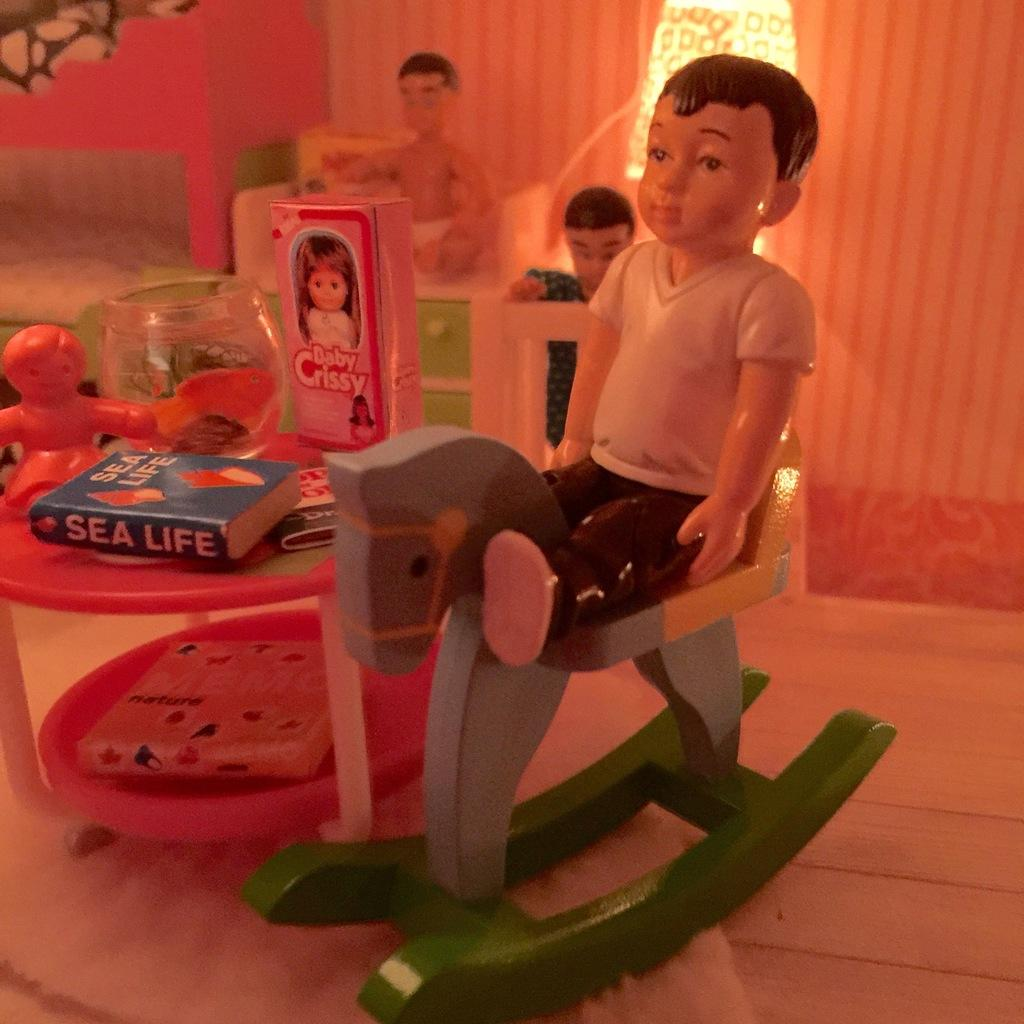What types of objects can be seen in the image? There are toys and books in the image. Can you describe the light in the image? There is a light in the image, but its specific characteristics are not mentioned. What might the toys and books be used for? The toys and books might be used for play and reading, respectively. Can you describe the bird flying in the image? There is no bird present in the image; it only features toys, books, and a light. 